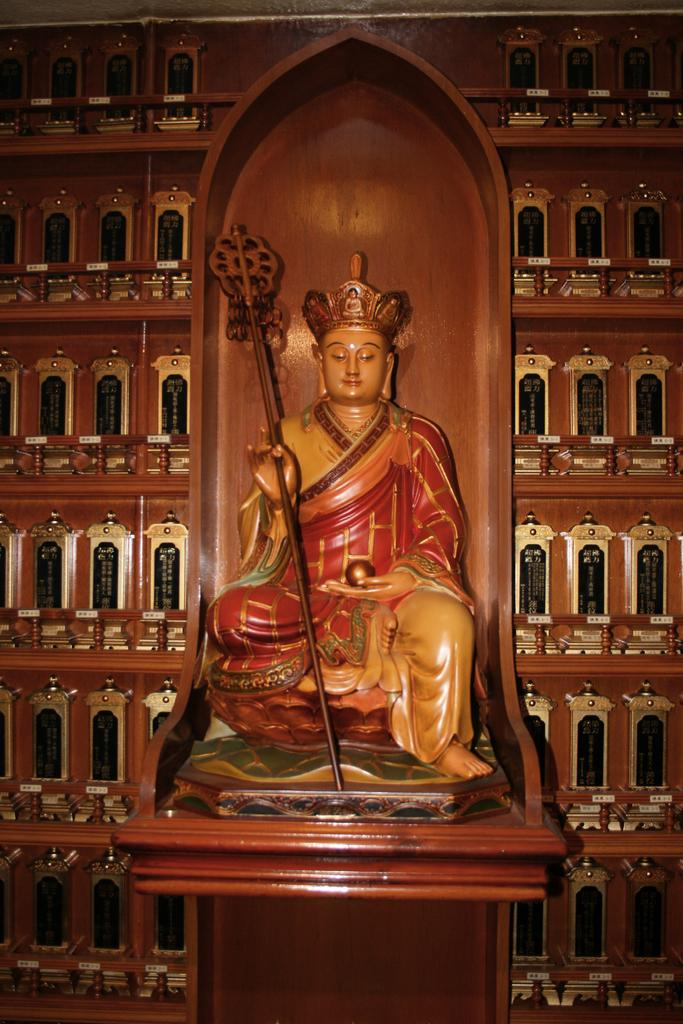What is the main subject of the image? There is a sculpture of a person in the image. What is the person in the sculpture holding? The person is holding a stick and a ball. What is located behind the sculpture? There is a wall behind the sculpture. Can you describe any additional features of the wall? There might be windows on the wall. What type of teeth can be seen in the sculpture? There are no teeth visible in the sculpture, as it is a sculpture of a person holding a stick and a ball. 